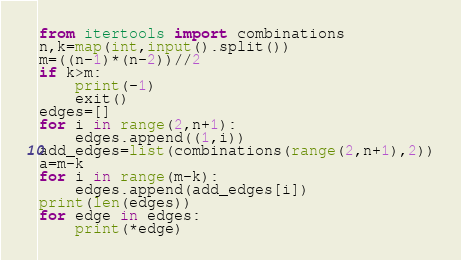<code> <loc_0><loc_0><loc_500><loc_500><_Python_>from itertools import combinations
n,k=map(int,input().split())
m=((n-1)*(n-2))//2
if k>m:
    print(-1)
    exit()
edges=[]
for i in range(2,n+1):
    edges.append((1,i))
add_edges=list(combinations(range(2,n+1),2))
a=m-k
for i in range(m-k):
    edges.append(add_edges[i])
print(len(edges))
for edge in edges:
    print(*edge)</code> 